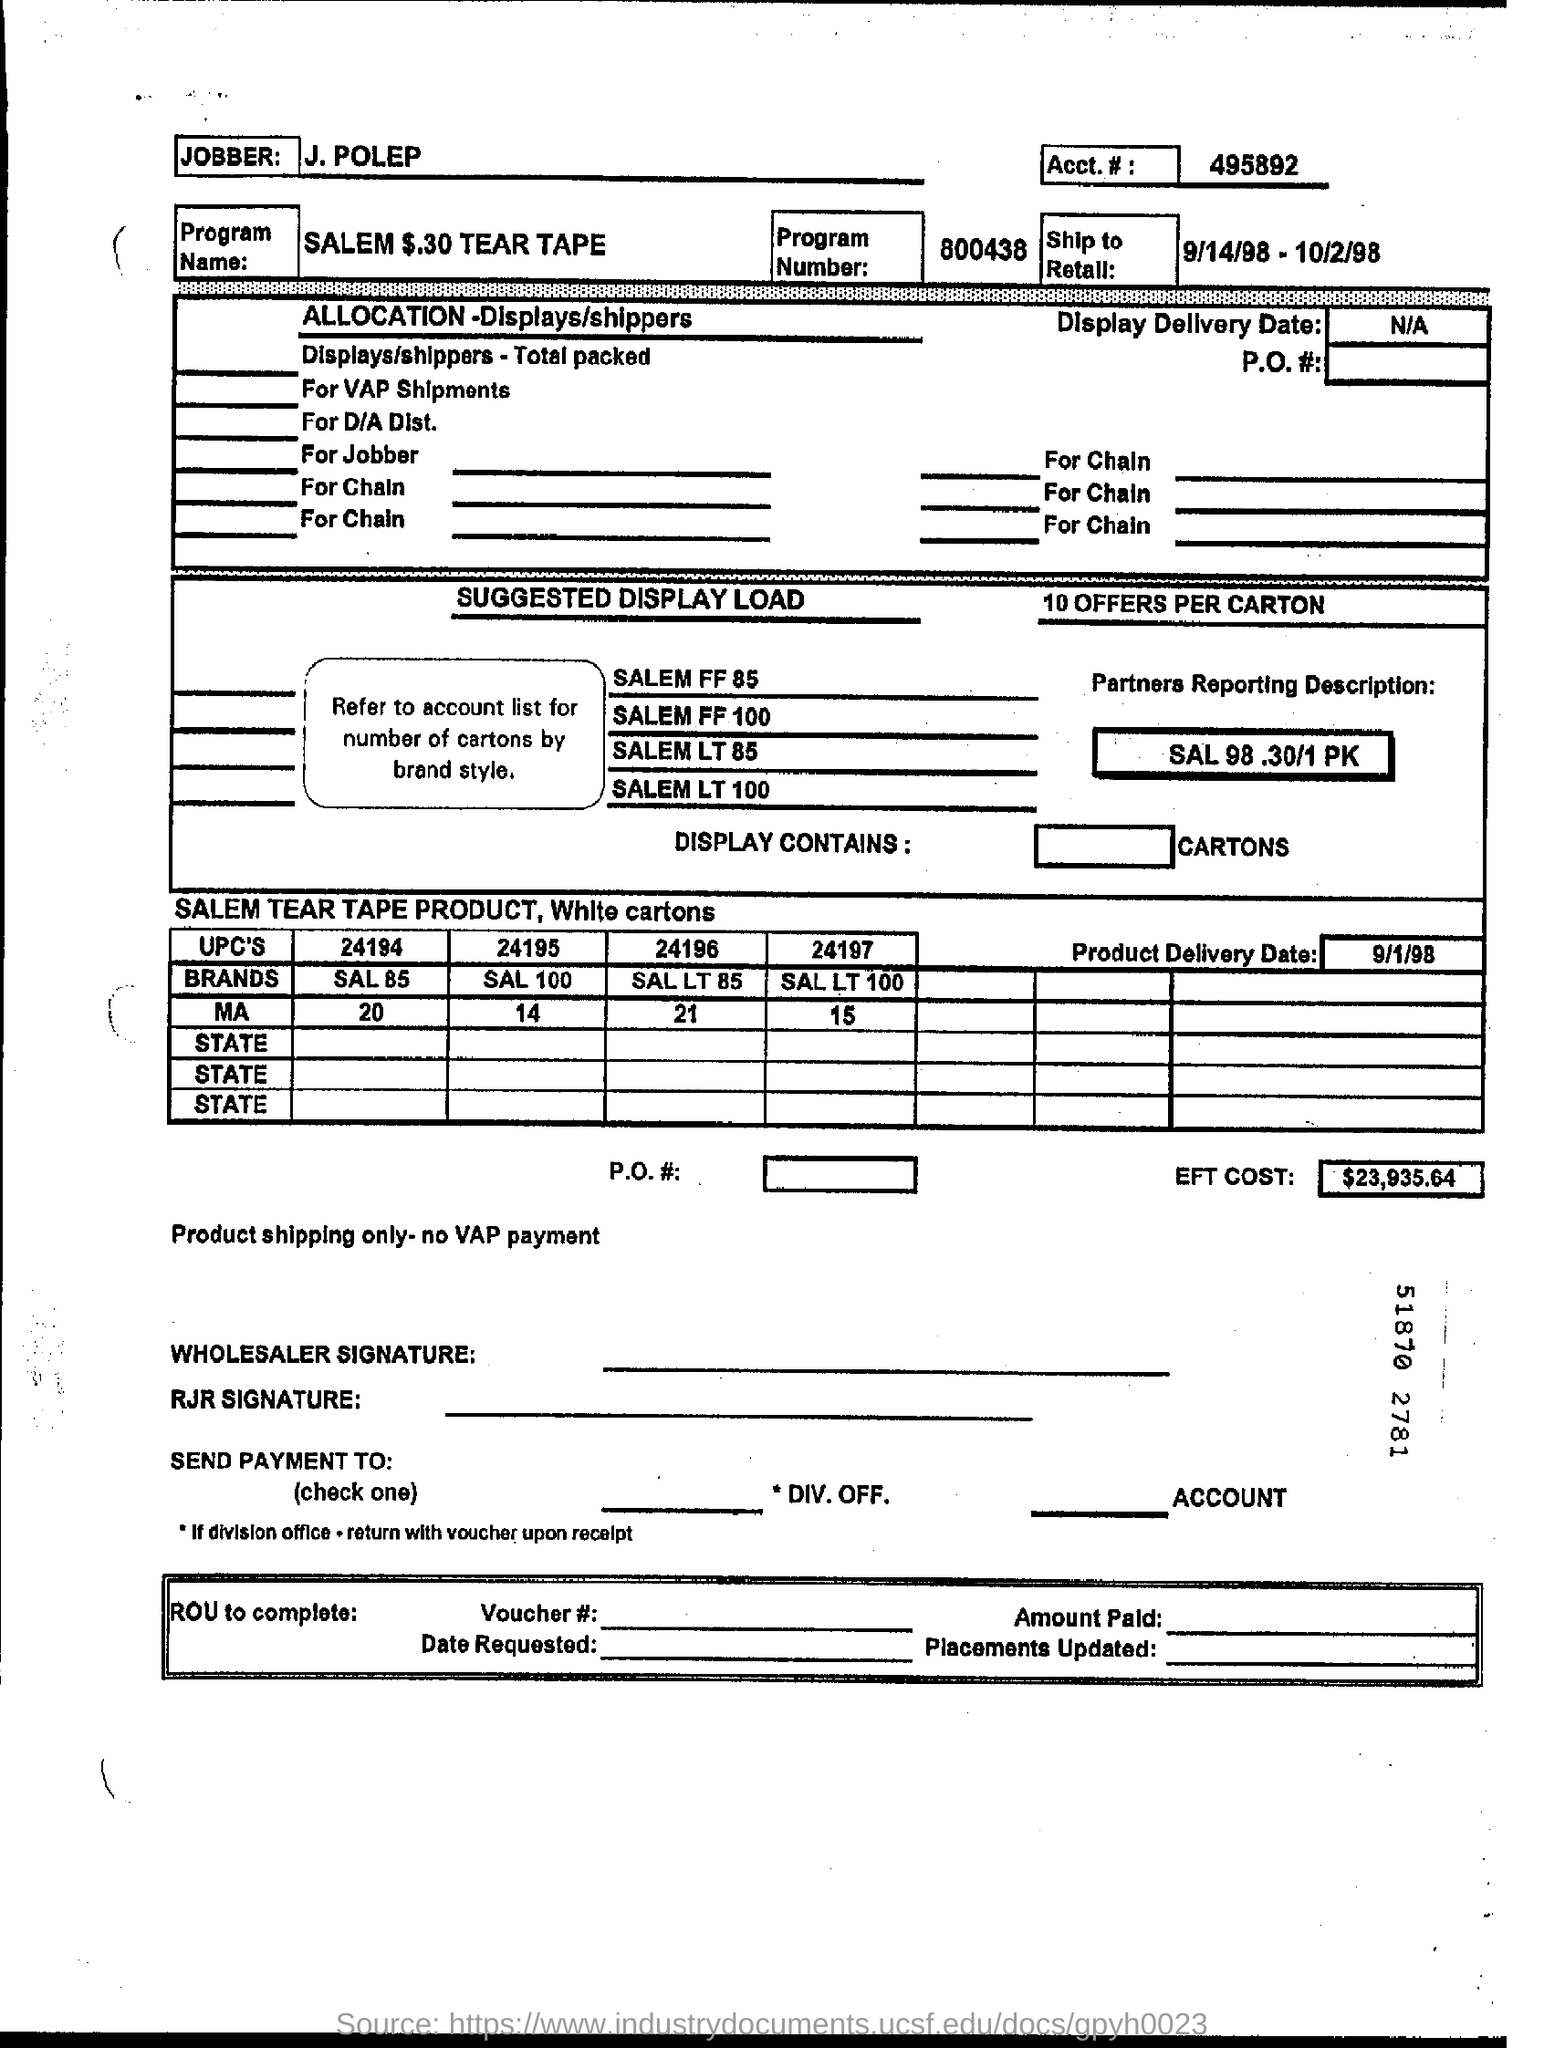What is the Program Name?
Offer a terse response. SALEM $.30 TEAR TAPE. What is Acct. #?
Provide a short and direct response. 495892. What is the Program Number?
Your answer should be very brief. 800438. Who is the Jobber?
Offer a very short reply. J. Polep. What is the EFT. COST?
Your response must be concise. $23,935.64. 